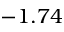Convert formula to latex. <formula><loc_0><loc_0><loc_500><loc_500>- 1 . 7 4</formula> 